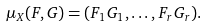<formula> <loc_0><loc_0><loc_500><loc_500>\mu _ { X } ( F , G ) = ( F _ { 1 } G _ { 1 } , \dots , F _ { r } G _ { r } ) .</formula> 